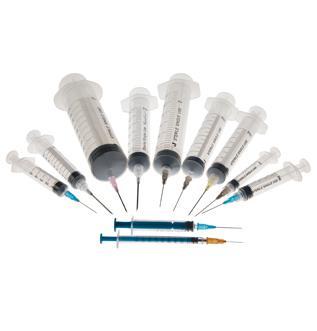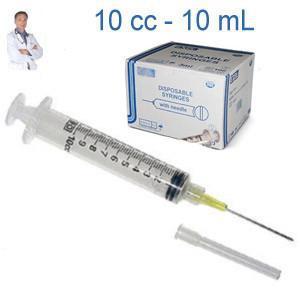The first image is the image on the left, the second image is the image on the right. Evaluate the accuracy of this statement regarding the images: "There is exactly one syringe in the left image.". Is it true? Answer yes or no. No. The first image is the image on the left, the second image is the image on the right. Evaluate the accuracy of this statement regarding the images: "There are 3 or fewer syringes total.". Is it true? Answer yes or no. No. 